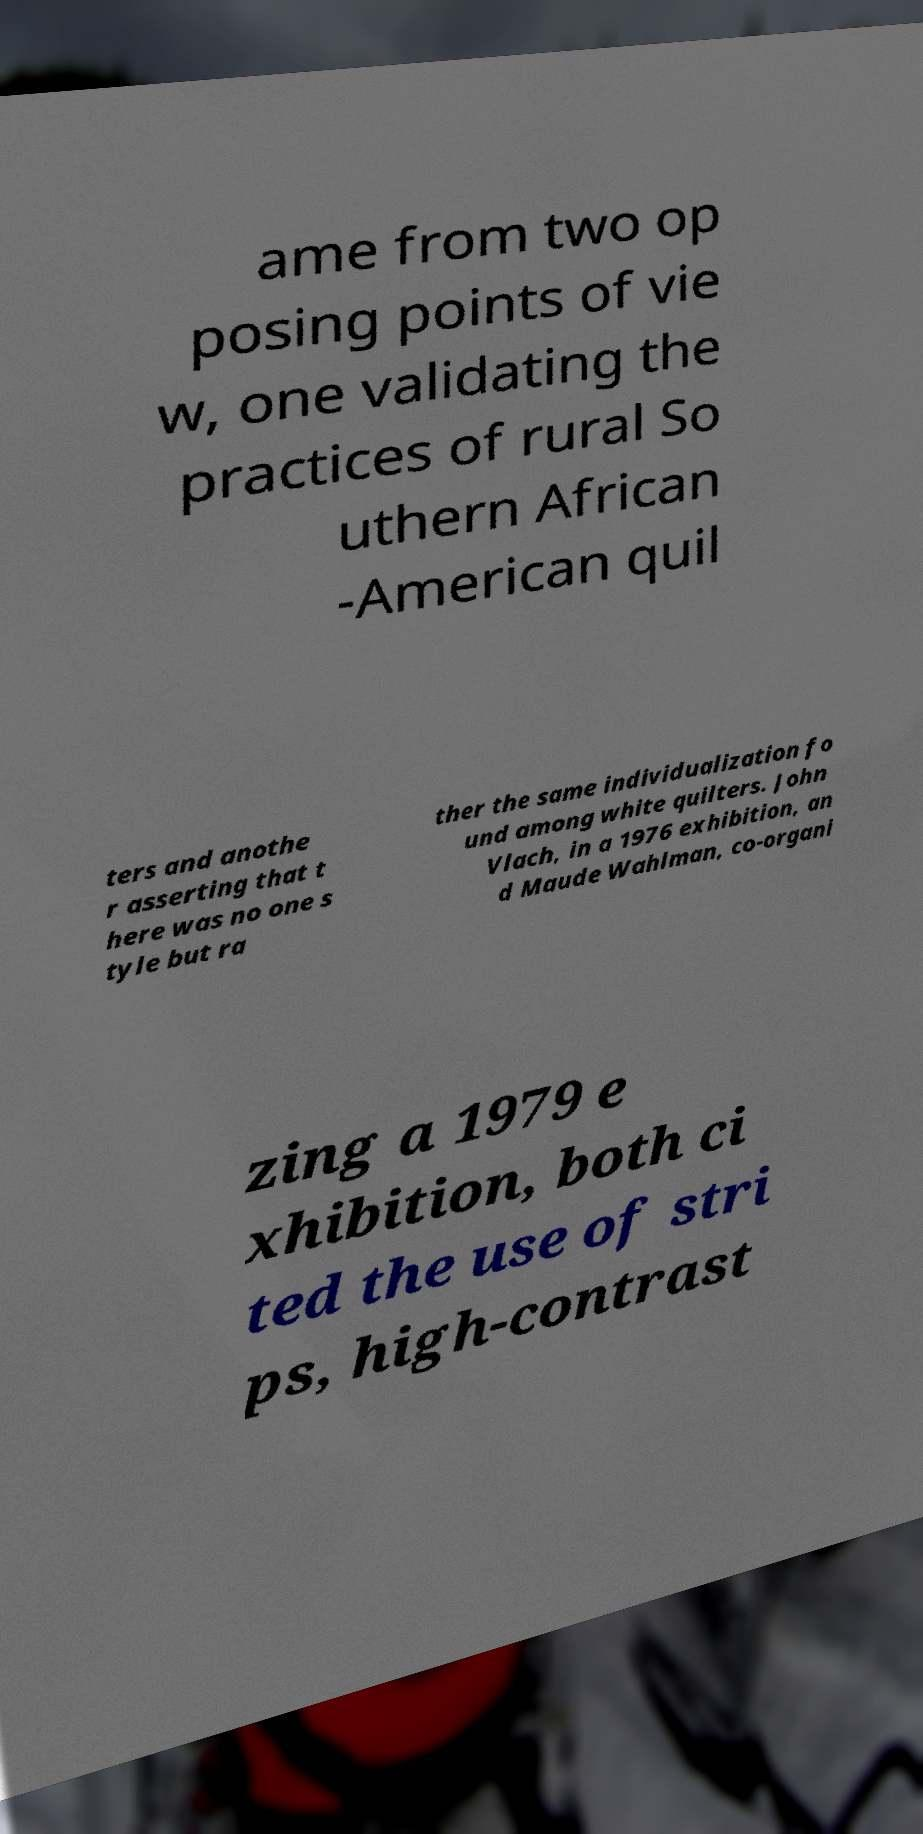For documentation purposes, I need the text within this image transcribed. Could you provide that? ame from two op posing points of vie w, one validating the practices of rural So uthern African -American quil ters and anothe r asserting that t here was no one s tyle but ra ther the same individualization fo und among white quilters. John Vlach, in a 1976 exhibition, an d Maude Wahlman, co-organi zing a 1979 e xhibition, both ci ted the use of stri ps, high-contrast 